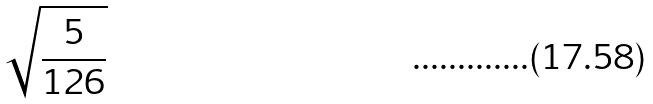Convert formula to latex. <formula><loc_0><loc_0><loc_500><loc_500>\sqrt { \frac { 5 } { 1 2 6 } }</formula> 